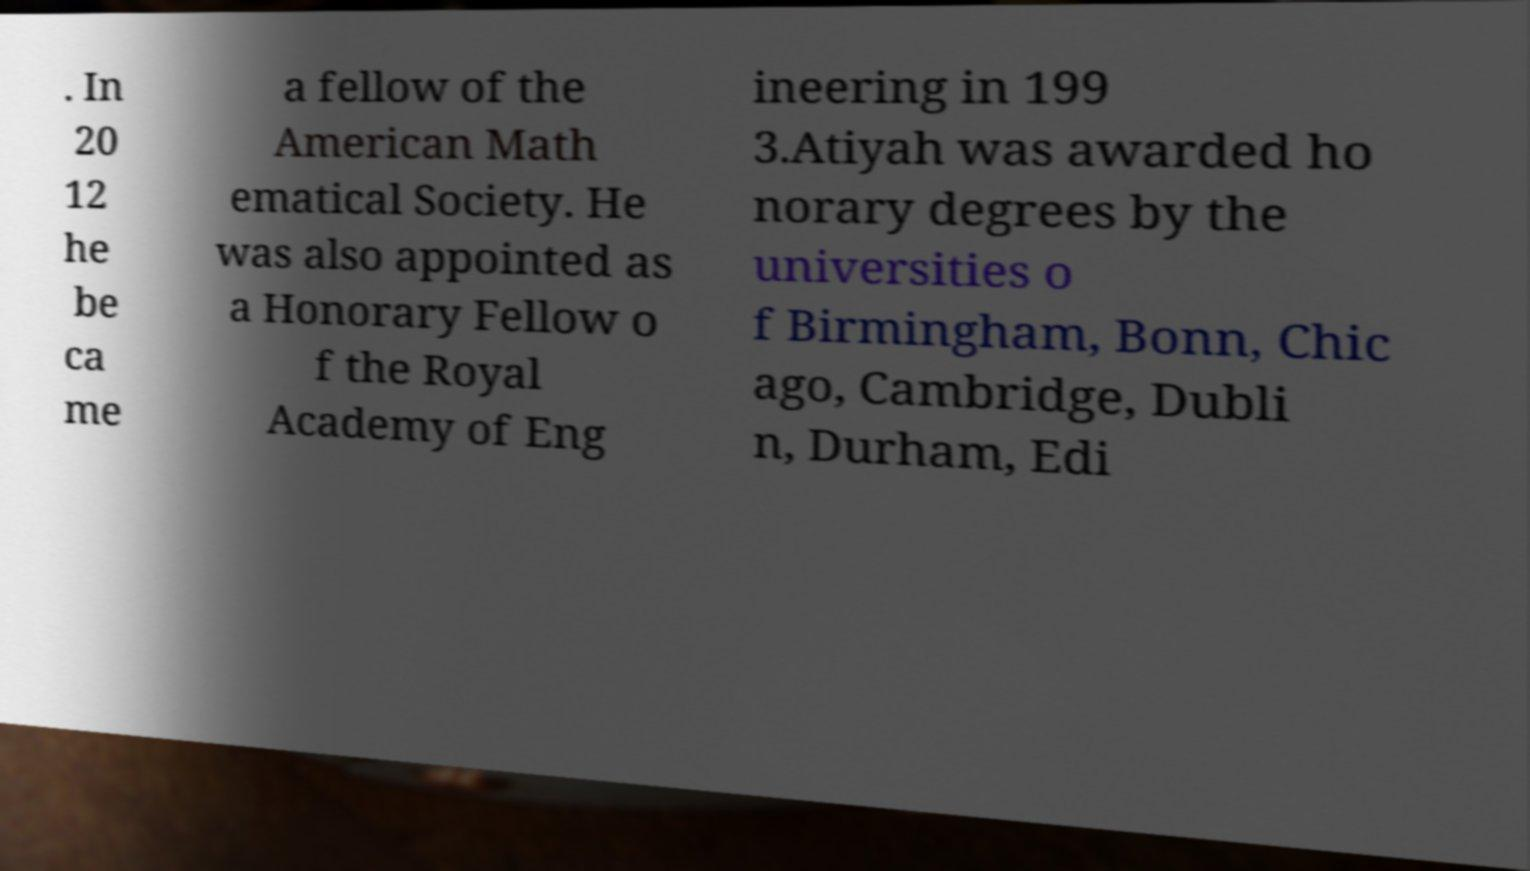Can you accurately transcribe the text from the provided image for me? . In 20 12 he be ca me a fellow of the American Math ematical Society. He was also appointed as a Honorary Fellow o f the Royal Academy of Eng ineering in 199 3.Atiyah was awarded ho norary degrees by the universities o f Birmingham, Bonn, Chic ago, Cambridge, Dubli n, Durham, Edi 